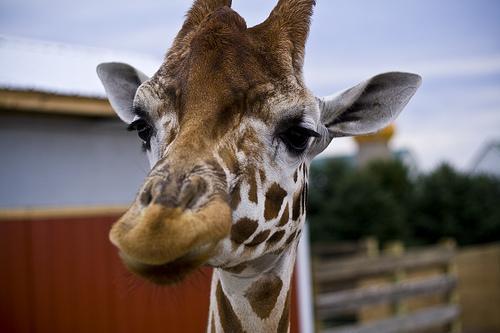How many giraffes?
Give a very brief answer. 1. 